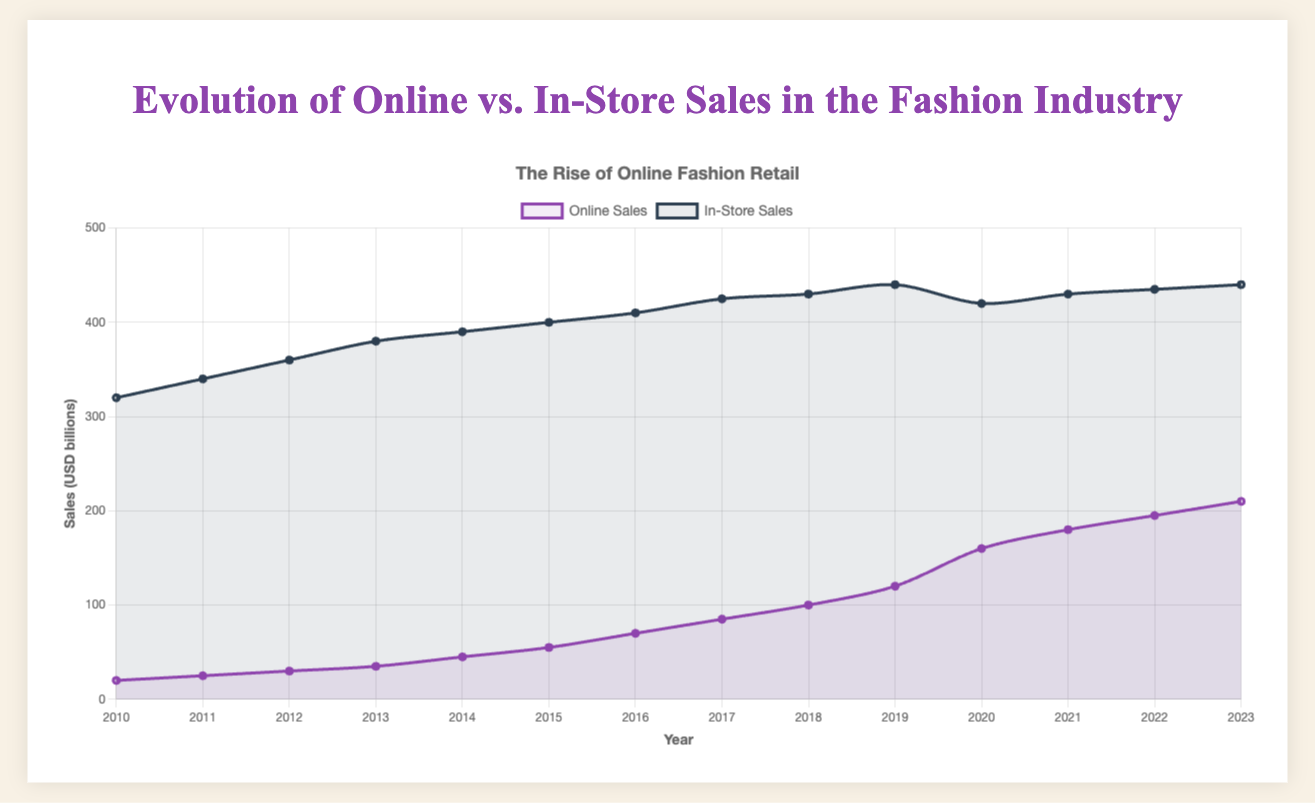What is the total sales (online and in-store) in 2023? Adding online and in-store sales for 2023: 210 (online) + 440 (in-store) = 650 USD billions
Answer: 650 USD billions Which year had the highest in-store sales? The highest in-store sales of 440 USD billions occurred in 2019 and 2023.
Answer: 2019 and 2023 What is the trend of online sales from 2010 to 2023? Online sales have been consistently increasing every year from 20 USD billions in 2010 to 210 USD billions in 2023.
Answer: Increasing How do the online sales in 2020 compare to those in 2010? Online sales in 2020 are 160 USD billions, whereas in 2010, they were 20 USD billions. 160 - 20 = 140 USD billions more in 2020.
Answer: 140 USD billions more in 2020 What is the percentage increase in in-store sales from 2010 to 2023? In-store sales in 2023 are 440 USD billions, and in 2010, they were 320 USD billions. The increase is 440 - 320 = 120 USD billions. The percentage increase is (120/320) * 100 = 37.5%.
Answer: 37.5% What was the impact of the year 2020 on in-store sales? In-store sales decreased from 440 USD billions in 2019 to 420 USD billions in 2020.
Answer: Decrease Which category (online or in-store) had a larger growth rate from 2010 to 2023? Online sales grew from 20 to 210 (190 USD billions increase) and in-store sales grew from 320 to 440 (120 USD billions increase). The growth rate for online sales (190/20) * 100 = 950%, and for in-store sales (120/320) * 100 = 37.5%.
Answer: Online sales How did online sales in 2022 compare to in-store sales in 2015? Online sales in 2022 were 195 USD billions whereas in-store sales in 2015 were 400 USD billions. 400 - 195 = 205 USD billions more for in-store sales in 2015.
Answer: 205 USD billions more for in-store sales in 2015 When did online sales first exceed 100 USD billions? Online sales first exceeded 100 USD billions in 2018 with 100 USD billions.
Answer: 2018 By how much did online sales exceed in-store sales in 2023 as compared to 2010? In 2010, online sales were 20 USD billions and in-store sales were 320 USD billions (300 USD billions difference). In 2023, online sales were 210 USD billions and in-store sales were 440 USD billions (230 USD billions difference). The change in the difference is 300 - 230 = 70 USD billions.
Answer: 70 USD billions 